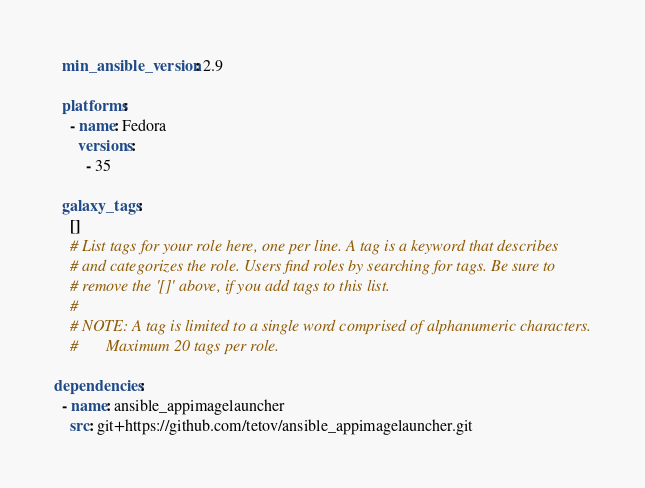Convert code to text. <code><loc_0><loc_0><loc_500><loc_500><_YAML_>
  min_ansible_version: 2.9

  platforms:
    - name: Fedora
      versions:
        - 35

  galaxy_tags:
    []
    # List tags for your role here, one per line. A tag is a keyword that describes
    # and categorizes the role. Users find roles by searching for tags. Be sure to
    # remove the '[]' above, if you add tags to this list.
    #
    # NOTE: A tag is limited to a single word comprised of alphanumeric characters.
    #       Maximum 20 tags per role.

dependencies:
  - name: ansible_appimagelauncher
    src: git+https://github.com/tetov/ansible_appimagelauncher.git
</code> 